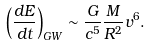Convert formula to latex. <formula><loc_0><loc_0><loc_500><loc_500>\left ( \frac { d E } { d t } \right ) _ { G W } \sim \frac { G } { c ^ { 5 } } \frac { M } { R ^ { 2 } } v ^ { 6 } .</formula> 